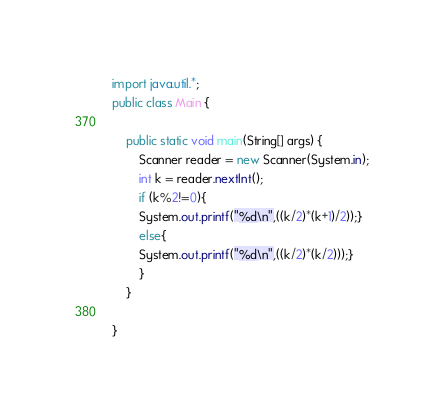Convert code to text. <code><loc_0><loc_0><loc_500><loc_500><_Java_>import java.util.*;
public class Main {

    public static void main(String[] args) {
        Scanner reader = new Scanner(System.in);
		int k = reader.nextInt();
        if (k%2!=0){
      	System.out.printf("%d\n",((k/2)*(k+1)/2));}
        else{
        System.out.printf("%d\n",((k/2)*(k/2)));}
        }
    }

}
</code> 